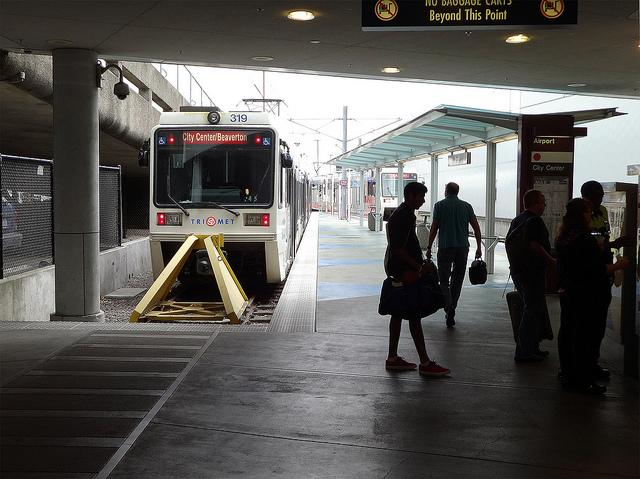The people carrying bags are doing so because of what reason?

Choices:
A) shopping
B) commuting
C) weather
D) air travel air travel 